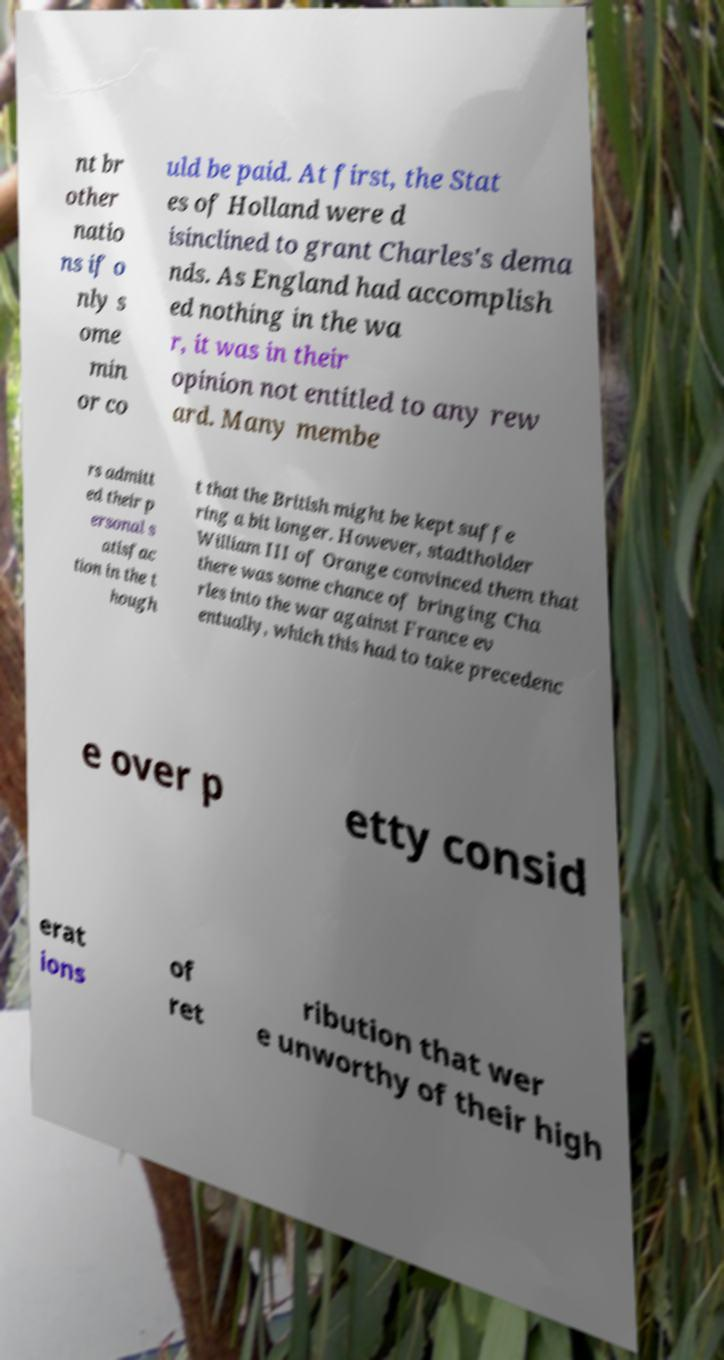Please read and relay the text visible in this image. What does it say? nt br other natio ns if o nly s ome min or co uld be paid. At first, the Stat es of Holland were d isinclined to grant Charles's dema nds. As England had accomplish ed nothing in the wa r, it was in their opinion not entitled to any rew ard. Many membe rs admitt ed their p ersonal s atisfac tion in the t hough t that the British might be kept suffe ring a bit longer. However, stadtholder William III of Orange convinced them that there was some chance of bringing Cha rles into the war against France ev entually, which this had to take precedenc e over p etty consid erat ions of ret ribution that wer e unworthy of their high 